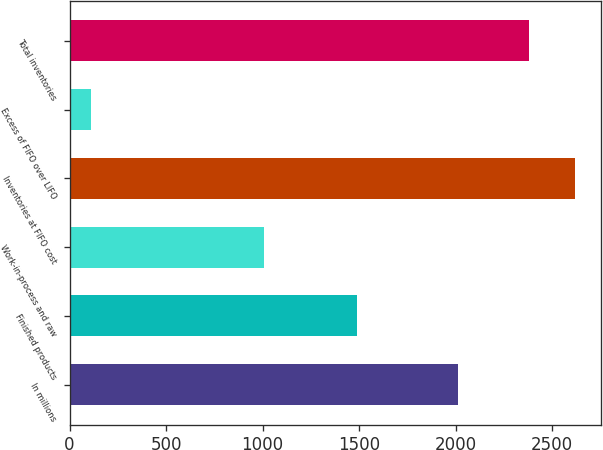Convert chart to OTSL. <chart><loc_0><loc_0><loc_500><loc_500><bar_chart><fcel>In millions<fcel>Finished products<fcel>Work-in-process and raw<fcel>Inventories at FIFO cost<fcel>Excess of FIFO over LIFO<fcel>Total inventories<nl><fcel>2013<fcel>1487<fcel>1005<fcel>2619.1<fcel>111<fcel>2381<nl></chart> 